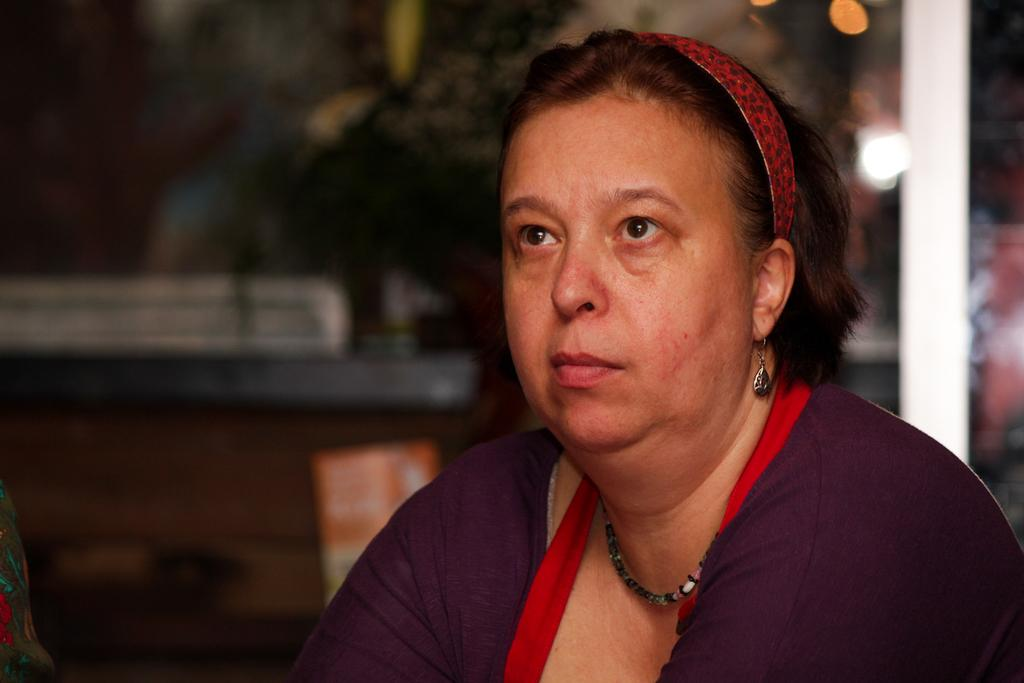Who is present in the image? There is a woman in the image. What is the woman wearing? The woman is wearing a purple dress, earrings, a chain, and a headband. Can you describe the background of the image? The background of the image is slightly blurred and dark. What type of beef is being served at the surprise basketball game in the image? There is no beef, surprise, or basketball game present in the image. 